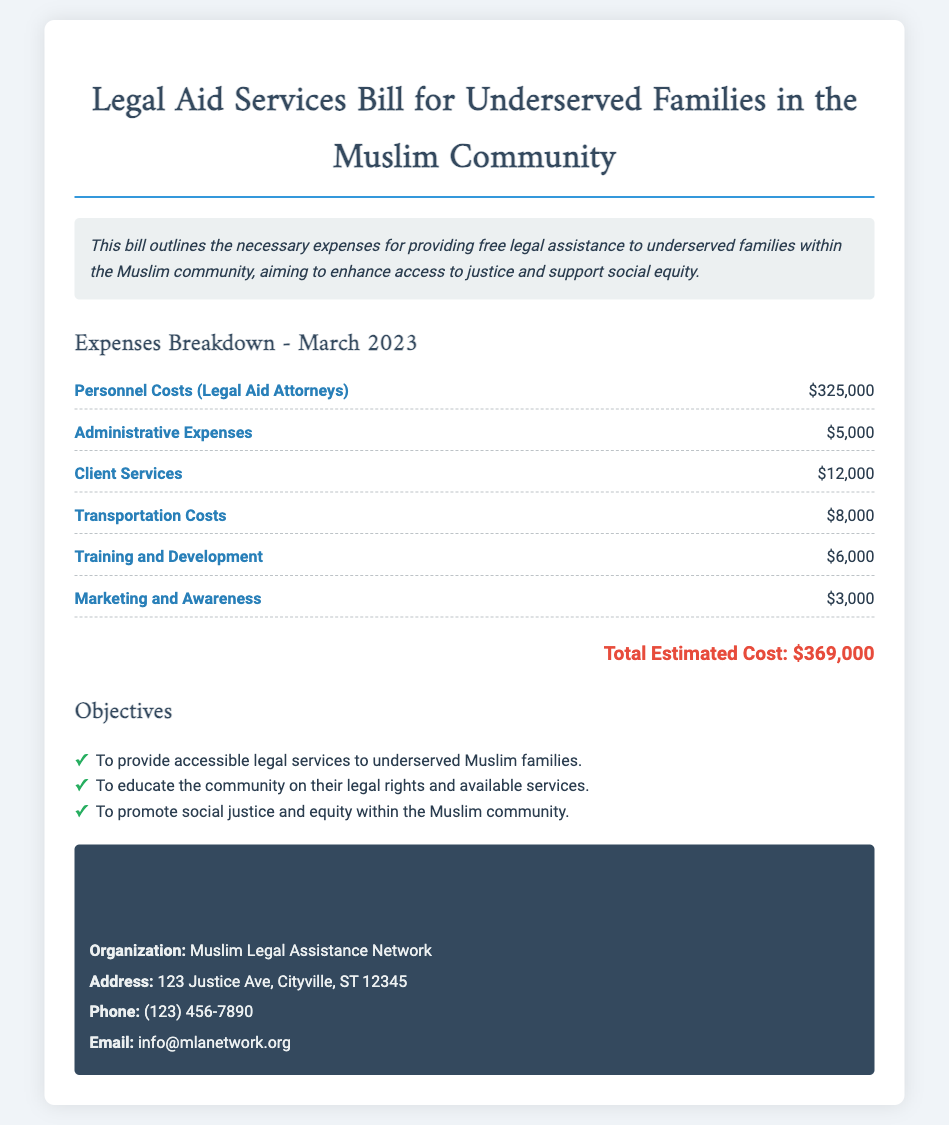What is the total estimated cost? The total estimated cost is stated at the bottom of the expenses section in the document.
Answer: $369,000 What is the main purpose of the bill? The summary outlines that the bill aims to provide legal assistance to underserved families.
Answer: Free legal assistance What is the expense for Personnel Costs? The specific amount for Personnel Costs is provided in the expense breakdown.
Answer: $325,000 How much is allocated for Training and Development? The expense breakdown includes a specific allocation for Training and Development.
Answer: $6,000 What organization is mentioned in the contact information? The document provides the name of the organization responsible for the legal aid services.
Answer: Muslim Legal Assistance Network What is the transportation cost? The expense breakdown lists the Transportation Costs separately.
Answer: $8,000 What is one of the objectives of the bill? The objectives section lists the goals of the bill, which can be referenced.
Answer: To provide accessible legal services to underserved Muslim families How much is allocated for Marketing and Awareness? The expense breakdown includes a specific amount for Marketing and Awareness expenses.
Answer: $3,000 What is the address of the organization? The document provides specific contact information, including the address.
Answer: 123 Justice Ave, Cityville, ST 12345 